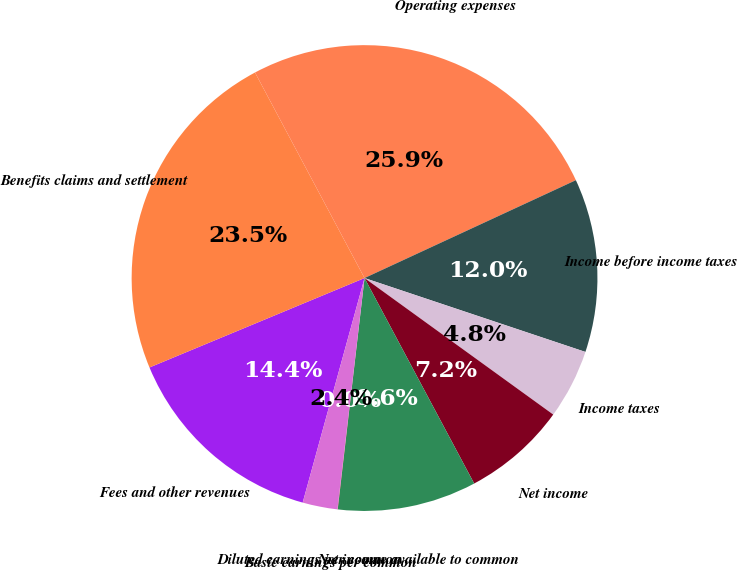<chart> <loc_0><loc_0><loc_500><loc_500><pie_chart><fcel>Fees and other revenues<fcel>Benefits claims and settlement<fcel>Operating expenses<fcel>Income before income taxes<fcel>Income taxes<fcel>Net income<fcel>Net income available to common<fcel>Basic earnings per common<fcel>Diluted earnings per common<nl><fcel>14.45%<fcel>23.48%<fcel>25.89%<fcel>12.04%<fcel>4.83%<fcel>7.23%<fcel>9.64%<fcel>0.02%<fcel>2.42%<nl></chart> 